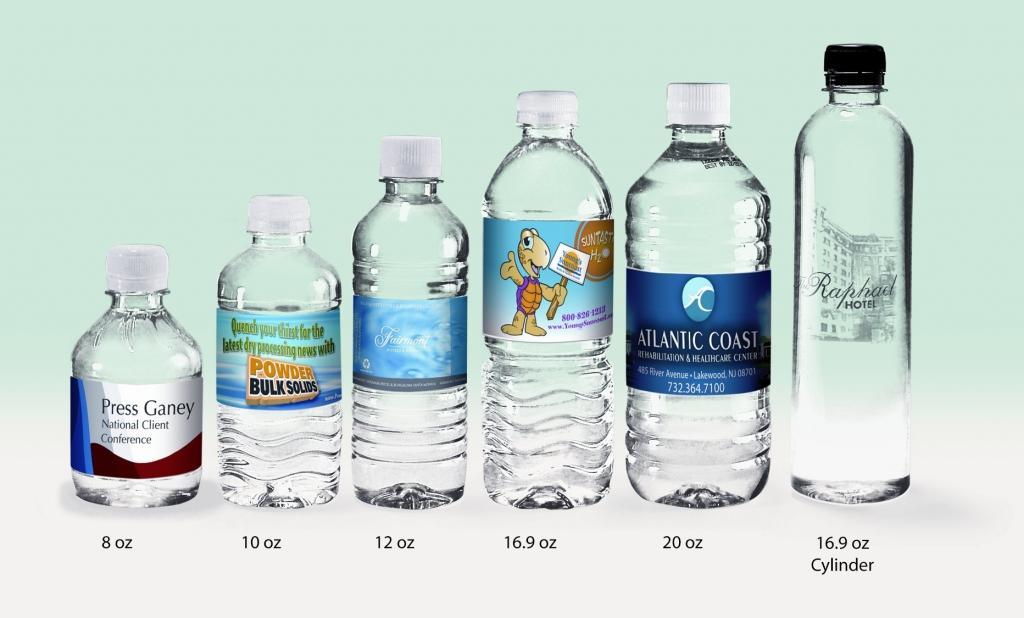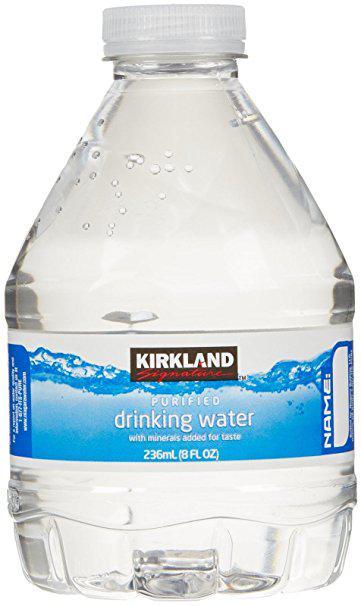The first image is the image on the left, the second image is the image on the right. For the images displayed, is the sentence "The bottle on the right has a blue label." factually correct? Answer yes or no. Yes. The first image is the image on the left, the second image is the image on the right. Evaluate the accuracy of this statement regarding the images: "One of the bottles has a Kirkland label.". Is it true? Answer yes or no. Yes. 